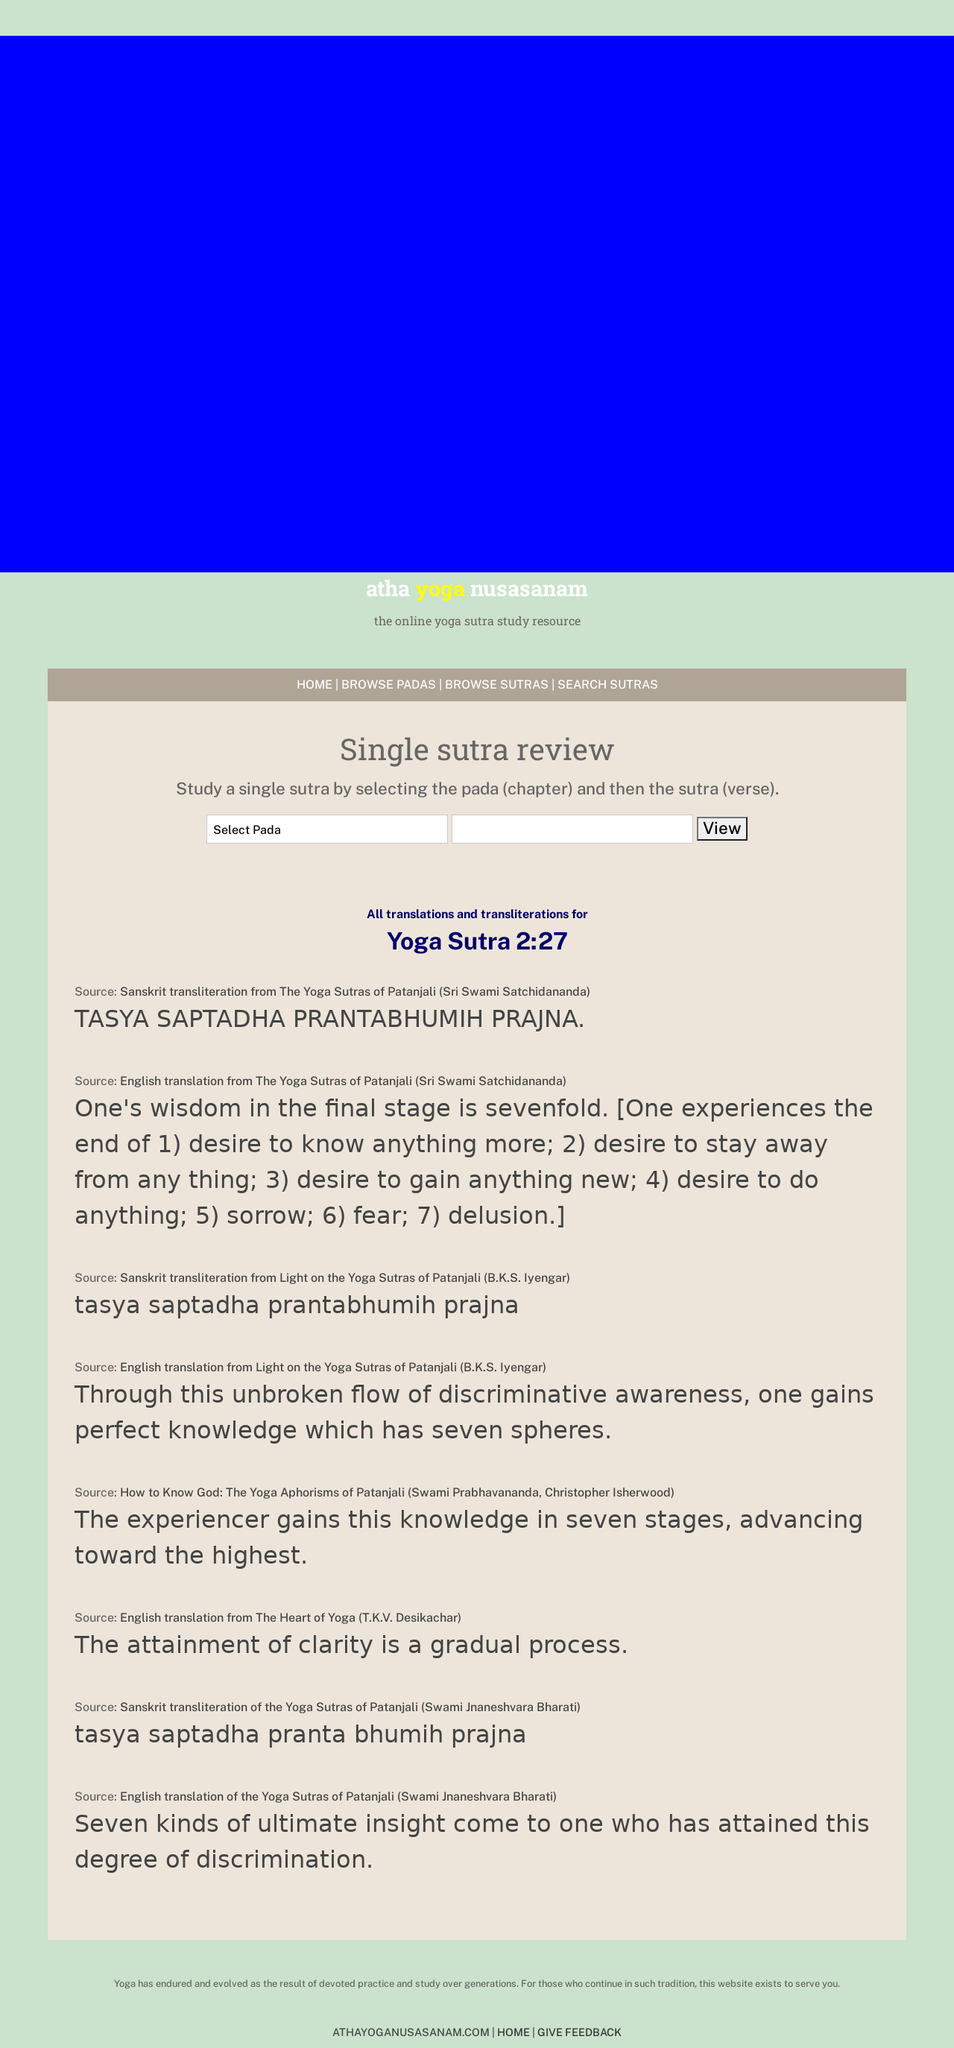Can you explain more about the significance of the color scheme used in the website as shown in the image? The website utilizes a calm and serene color palette, predominantly using shades of blue and earth tones. These colors are often associated with tranquility, stability, and nature, which align well with the themes of yoga and meditation. The use of such colors can help in creating a soothing experience for visitors, potentially enhancing their learning and reflective processes on the site. 